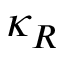<formula> <loc_0><loc_0><loc_500><loc_500>\kappa _ { R }</formula> 